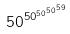<formula> <loc_0><loc_0><loc_500><loc_500>5 0 ^ { 5 0 ^ { 5 0 ^ { 5 0 ^ { 5 9 } } } }</formula> 